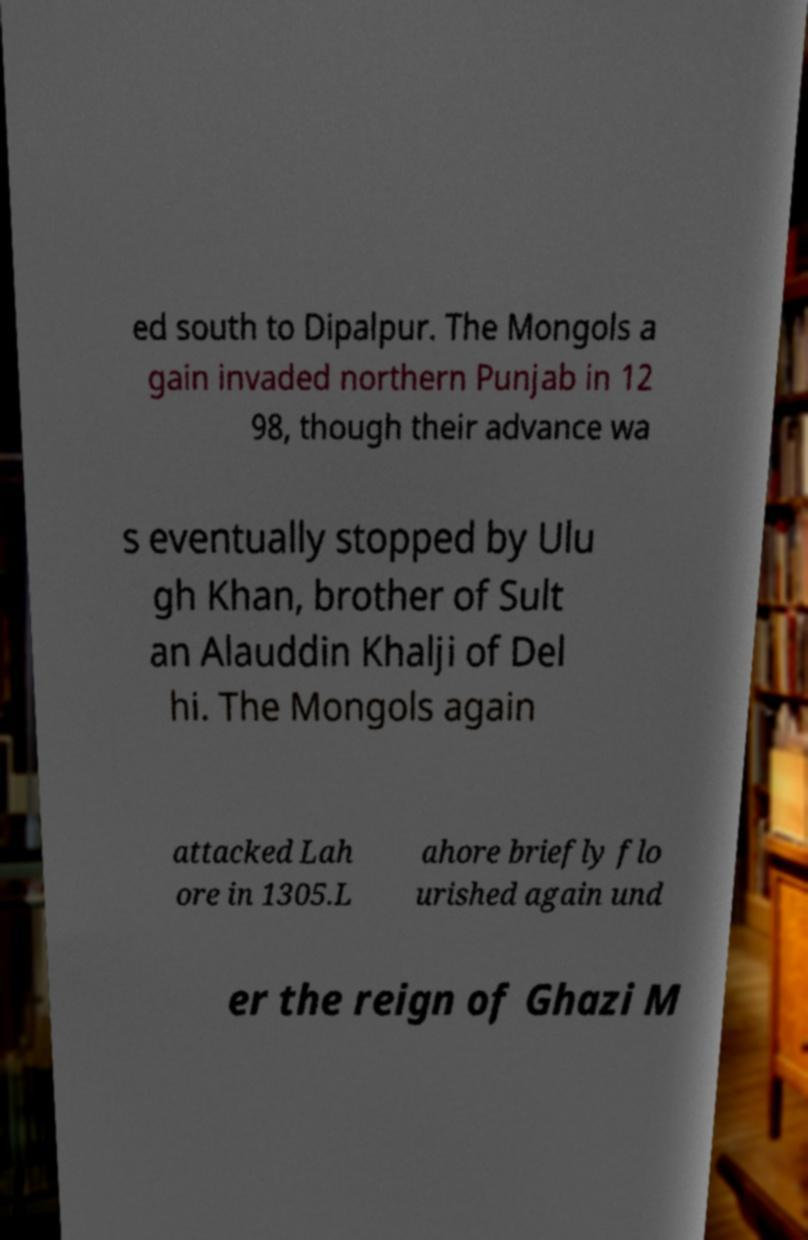Please identify and transcribe the text found in this image. ed south to Dipalpur. The Mongols a gain invaded northern Punjab in 12 98, though their advance wa s eventually stopped by Ulu gh Khan, brother of Sult an Alauddin Khalji of Del hi. The Mongols again attacked Lah ore in 1305.L ahore briefly flo urished again und er the reign of Ghazi M 